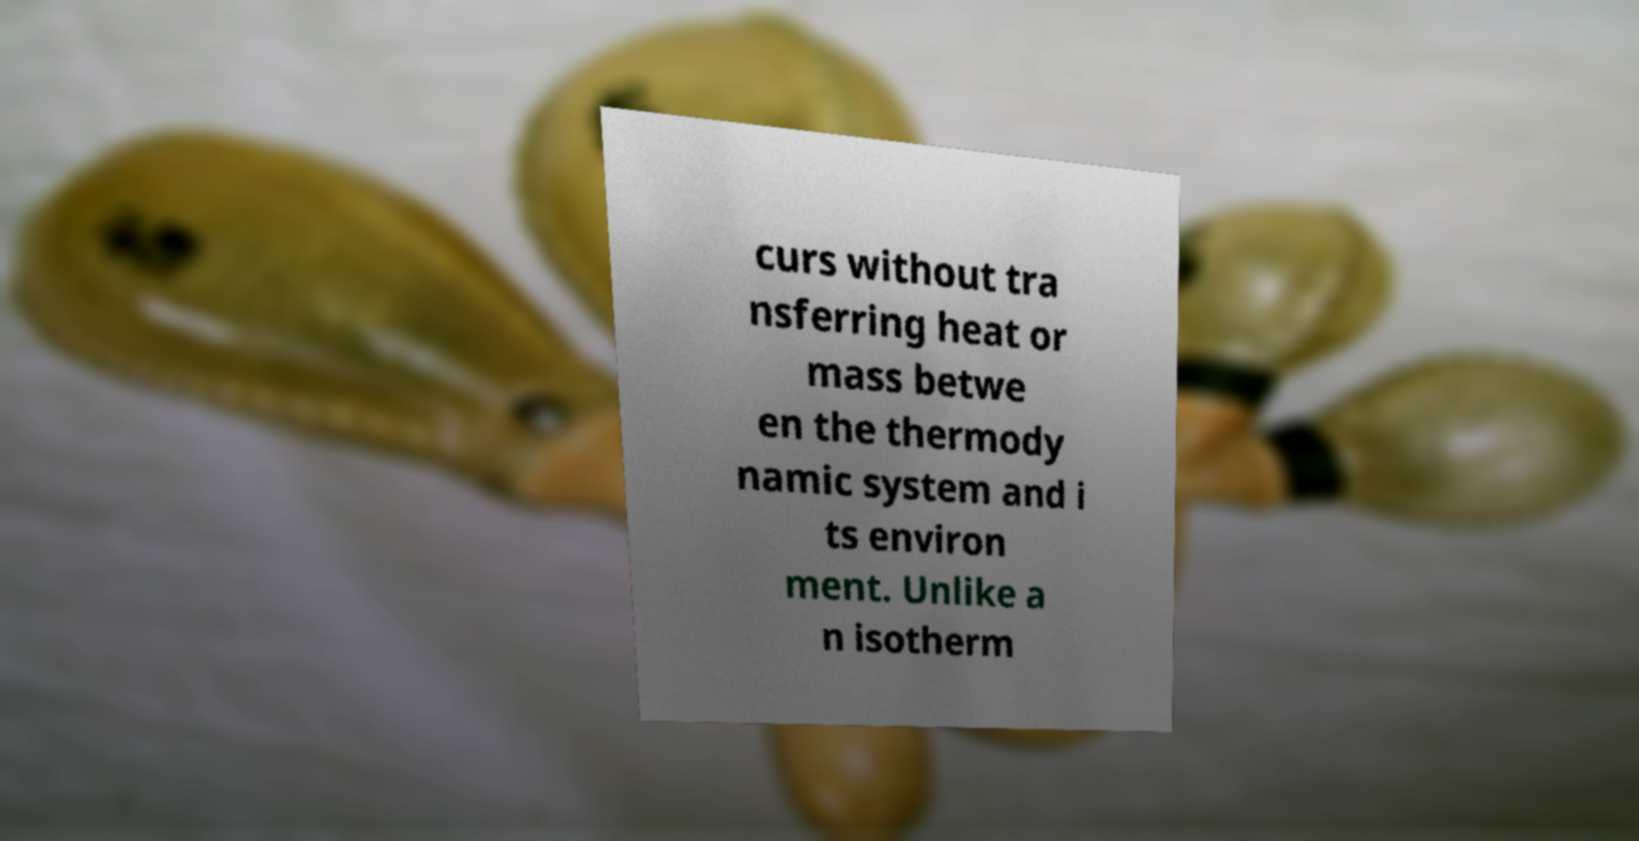For documentation purposes, I need the text within this image transcribed. Could you provide that? curs without tra nsferring heat or mass betwe en the thermody namic system and i ts environ ment. Unlike a n isotherm 